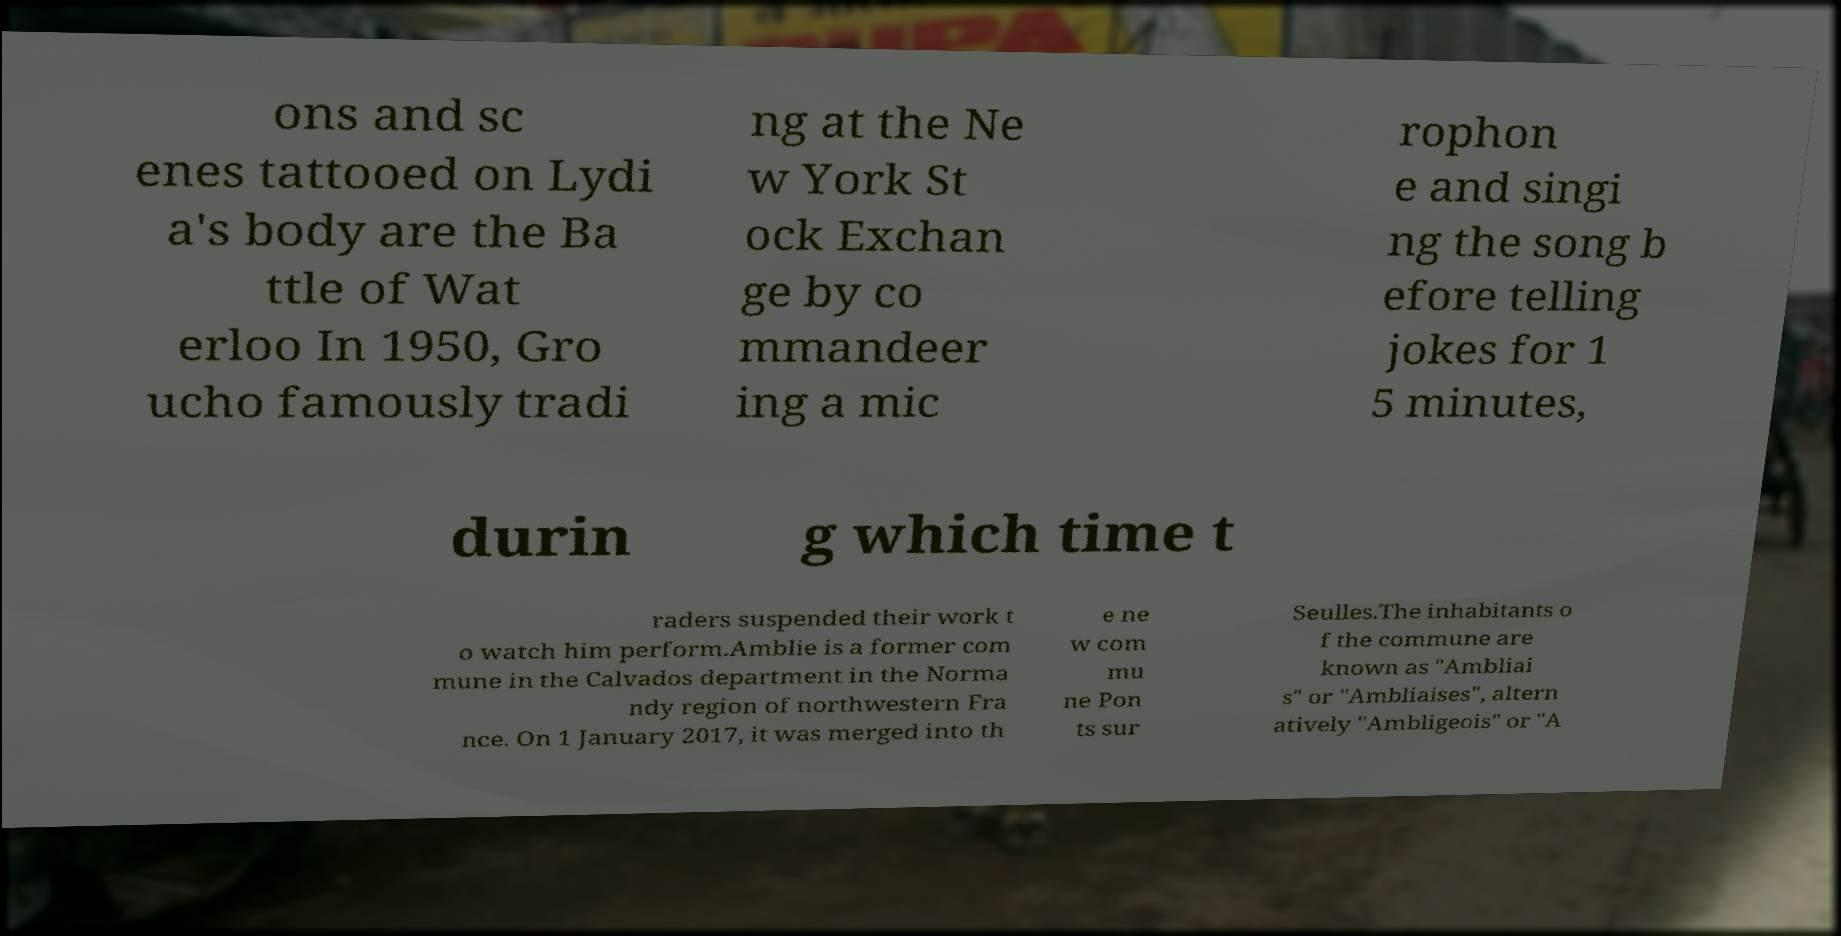Please identify and transcribe the text found in this image. ons and sc enes tattooed on Lydi a's body are the Ba ttle of Wat erloo In 1950, Gro ucho famously tradi ng at the Ne w York St ock Exchan ge by co mmandeer ing a mic rophon e and singi ng the song b efore telling jokes for 1 5 minutes, durin g which time t raders suspended their work t o watch him perform.Amblie is a former com mune in the Calvados department in the Norma ndy region of northwestern Fra nce. On 1 January 2017, it was merged into th e ne w com mu ne Pon ts sur Seulles.The inhabitants o f the commune are known as "Ambliai s" or "Ambliaises", altern atively "Ambligeois" or "A 